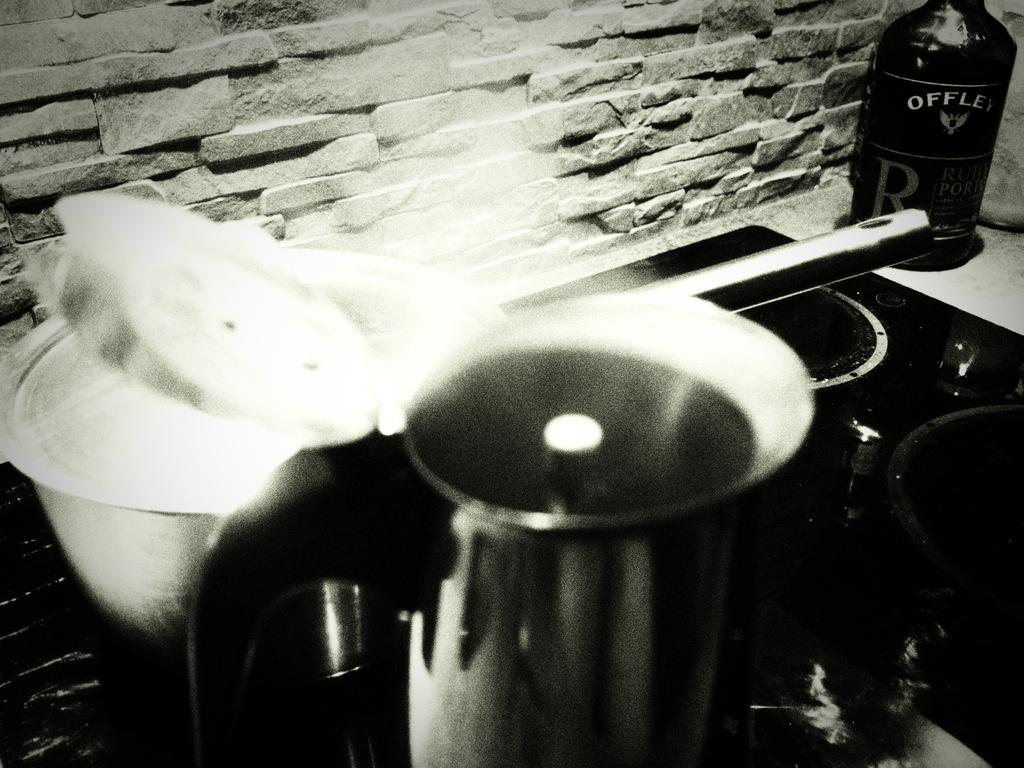What is the color scheme of the image? The image is black and white. What can be seen on the gas stove in the image? There are two vessels on the gas stove. What is located beside the gas stove? There is a bottle beside the gas stove. What can be seen in the background of the image? There is a wall in the background of the image. What type of berry is being used to fuel the gas stove in the image? There are no berries present in the image, and berries are not used to fuel gas stoves. 